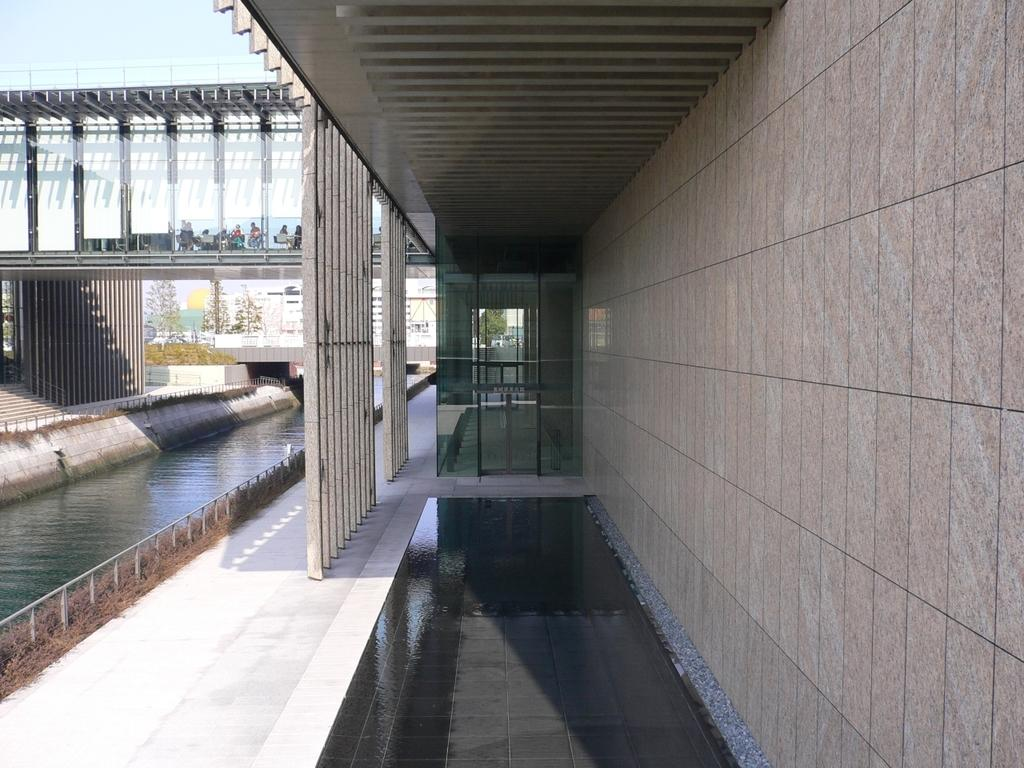What can be seen in the left corner of the image? There is water and people sitting in the left corner of the image. What is above the water in the image? There is a bridge above the water in the image. What is visible in the background of the image? There are buildings in the background of the image. How many babies are crawling on the bridge in the image? There are no babies present in the image, and therefore no crawling babies can be observed on the bridge. What type of respect can be seen being given to the water in the image? There is no indication of respect being given to the water in the image; it is simply a body of water. 